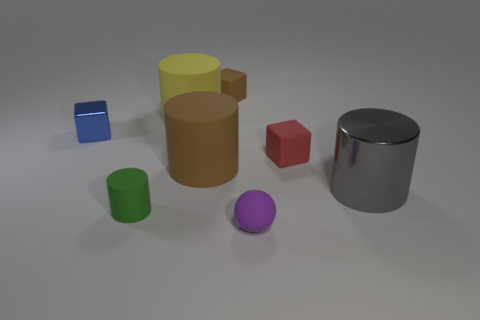Subtract all yellow matte cylinders. How many cylinders are left? 3 Add 1 purple rubber things. How many objects exist? 9 Subtract all gray cylinders. How many cylinders are left? 3 Subtract all blocks. How many objects are left? 5 Subtract 1 blue blocks. How many objects are left? 7 Subtract 2 blocks. How many blocks are left? 1 Subtract all blue balls. Subtract all red cylinders. How many balls are left? 1 Subtract all red spheres. How many red cylinders are left? 0 Subtract all large rubber things. Subtract all matte cylinders. How many objects are left? 3 Add 1 small spheres. How many small spheres are left? 2 